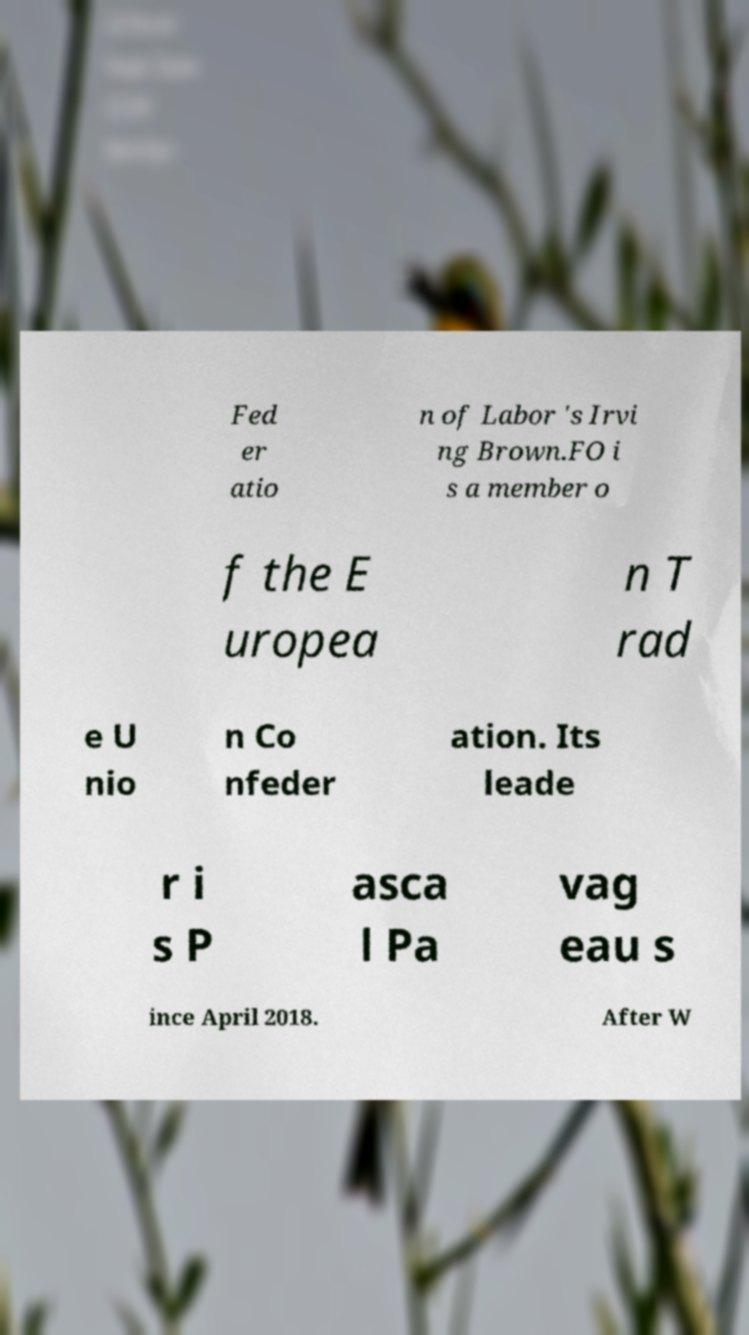Can you accurately transcribe the text from the provided image for me? Fed er atio n of Labor 's Irvi ng Brown.FO i s a member o f the E uropea n T rad e U nio n Co nfeder ation. Its leade r i s P asca l Pa vag eau s ince April 2018. After W 